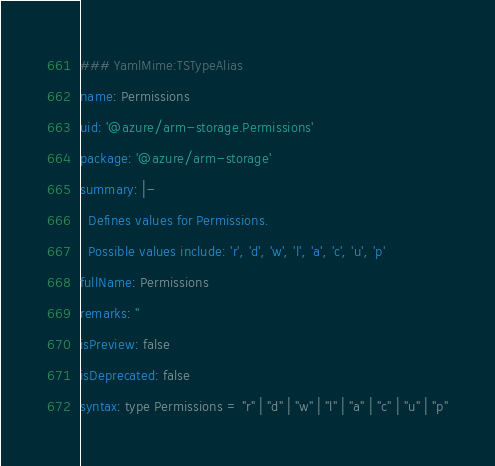<code> <loc_0><loc_0><loc_500><loc_500><_YAML_>### YamlMime:TSTypeAlias
name: Permissions
uid: '@azure/arm-storage.Permissions'
package: '@azure/arm-storage'
summary: |-
  Defines values for Permissions.
  Possible values include: 'r', 'd', 'w', 'l', 'a', 'c', 'u', 'p'
fullName: Permissions
remarks: ''
isPreview: false
isDeprecated: false
syntax: type Permissions = "r" | "d" | "w" | "l" | "a" | "c" | "u" | "p"
</code> 